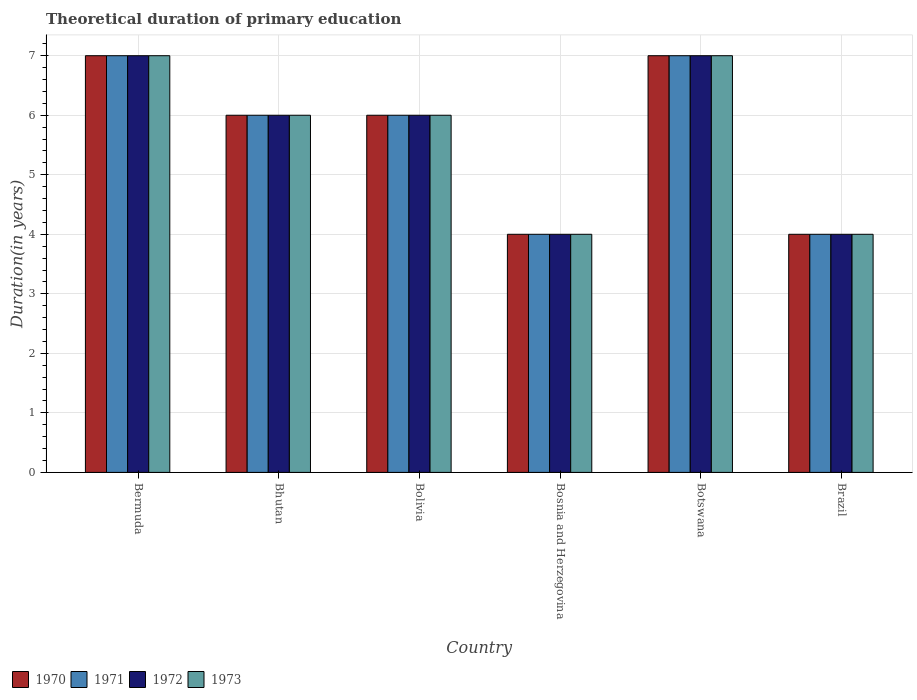How many different coloured bars are there?
Your answer should be compact. 4. Are the number of bars per tick equal to the number of legend labels?
Provide a succinct answer. Yes. How many bars are there on the 1st tick from the left?
Your answer should be very brief. 4. What is the label of the 6th group of bars from the left?
Ensure brevity in your answer.  Brazil. In how many cases, is the number of bars for a given country not equal to the number of legend labels?
Your answer should be very brief. 0. Across all countries, what is the minimum total theoretical duration of primary education in 1973?
Your answer should be compact. 4. In which country was the total theoretical duration of primary education in 1972 maximum?
Keep it short and to the point. Bermuda. In which country was the total theoretical duration of primary education in 1971 minimum?
Your answer should be compact. Bosnia and Herzegovina. What is the average total theoretical duration of primary education in 1970 per country?
Your answer should be compact. 5.67. What is the difference between the total theoretical duration of primary education of/in 1970 and total theoretical duration of primary education of/in 1971 in Botswana?
Give a very brief answer. 0. Is the difference between the total theoretical duration of primary education in 1970 in Bolivia and Bosnia and Herzegovina greater than the difference between the total theoretical duration of primary education in 1971 in Bolivia and Bosnia and Herzegovina?
Offer a terse response. No. What is the difference between the highest and the second highest total theoretical duration of primary education in 1973?
Offer a very short reply. -1. Is the sum of the total theoretical duration of primary education in 1972 in Bermuda and Bosnia and Herzegovina greater than the maximum total theoretical duration of primary education in 1971 across all countries?
Ensure brevity in your answer.  Yes. What does the 2nd bar from the left in Botswana represents?
Provide a succinct answer. 1971. How many bars are there?
Provide a short and direct response. 24. How many countries are there in the graph?
Offer a very short reply. 6. What is the difference between two consecutive major ticks on the Y-axis?
Ensure brevity in your answer.  1. Where does the legend appear in the graph?
Keep it short and to the point. Bottom left. What is the title of the graph?
Offer a very short reply. Theoretical duration of primary education. Does "1972" appear as one of the legend labels in the graph?
Keep it short and to the point. Yes. What is the label or title of the Y-axis?
Your response must be concise. Duration(in years). What is the Duration(in years) of 1970 in Bermuda?
Provide a short and direct response. 7. What is the Duration(in years) in 1971 in Bermuda?
Your response must be concise. 7. What is the Duration(in years) in 1973 in Bermuda?
Your answer should be very brief. 7. What is the Duration(in years) in 1971 in Bhutan?
Your response must be concise. 6. What is the Duration(in years) of 1973 in Bhutan?
Provide a succinct answer. 6. What is the Duration(in years) in 1971 in Bolivia?
Your answer should be very brief. 6. What is the Duration(in years) of 1972 in Bosnia and Herzegovina?
Offer a very short reply. 4. What is the Duration(in years) of 1970 in Botswana?
Offer a terse response. 7. What is the Duration(in years) of 1971 in Botswana?
Your answer should be very brief. 7. What is the Duration(in years) of 1972 in Botswana?
Offer a terse response. 7. What is the Duration(in years) in 1970 in Brazil?
Your answer should be compact. 4. What is the Duration(in years) of 1972 in Brazil?
Offer a very short reply. 4. Across all countries, what is the maximum Duration(in years) in 1970?
Your response must be concise. 7. Across all countries, what is the maximum Duration(in years) in 1971?
Your response must be concise. 7. Across all countries, what is the maximum Duration(in years) in 1972?
Keep it short and to the point. 7. Across all countries, what is the maximum Duration(in years) in 1973?
Ensure brevity in your answer.  7. Across all countries, what is the minimum Duration(in years) in 1972?
Your answer should be compact. 4. What is the total Duration(in years) of 1972 in the graph?
Offer a very short reply. 34. What is the difference between the Duration(in years) in 1970 in Bermuda and that in Bhutan?
Keep it short and to the point. 1. What is the difference between the Duration(in years) in 1971 in Bermuda and that in Bhutan?
Make the answer very short. 1. What is the difference between the Duration(in years) in 1972 in Bermuda and that in Bhutan?
Your answer should be compact. 1. What is the difference between the Duration(in years) in 1973 in Bermuda and that in Bhutan?
Offer a very short reply. 1. What is the difference between the Duration(in years) of 1970 in Bermuda and that in Bolivia?
Give a very brief answer. 1. What is the difference between the Duration(in years) of 1971 in Bermuda and that in Bolivia?
Give a very brief answer. 1. What is the difference between the Duration(in years) of 1972 in Bermuda and that in Bosnia and Herzegovina?
Provide a short and direct response. 3. What is the difference between the Duration(in years) of 1973 in Bermuda and that in Bosnia and Herzegovina?
Ensure brevity in your answer.  3. What is the difference between the Duration(in years) of 1972 in Bermuda and that in Botswana?
Provide a succinct answer. 0. What is the difference between the Duration(in years) of 1973 in Bermuda and that in Botswana?
Your answer should be very brief. 0. What is the difference between the Duration(in years) of 1970 in Bermuda and that in Brazil?
Ensure brevity in your answer.  3. What is the difference between the Duration(in years) of 1972 in Bermuda and that in Brazil?
Your answer should be very brief. 3. What is the difference between the Duration(in years) in 1970 in Bhutan and that in Bolivia?
Ensure brevity in your answer.  0. What is the difference between the Duration(in years) in 1971 in Bhutan and that in Bolivia?
Keep it short and to the point. 0. What is the difference between the Duration(in years) in 1972 in Bhutan and that in Bolivia?
Provide a short and direct response. 0. What is the difference between the Duration(in years) of 1973 in Bhutan and that in Bolivia?
Your answer should be very brief. 0. What is the difference between the Duration(in years) of 1970 in Bhutan and that in Bosnia and Herzegovina?
Give a very brief answer. 2. What is the difference between the Duration(in years) of 1971 in Bhutan and that in Bosnia and Herzegovina?
Give a very brief answer. 2. What is the difference between the Duration(in years) in 1972 in Bhutan and that in Bosnia and Herzegovina?
Your answer should be compact. 2. What is the difference between the Duration(in years) in 1971 in Bhutan and that in Botswana?
Make the answer very short. -1. What is the difference between the Duration(in years) of 1970 in Bhutan and that in Brazil?
Give a very brief answer. 2. What is the difference between the Duration(in years) in 1970 in Bolivia and that in Bosnia and Herzegovina?
Your response must be concise. 2. What is the difference between the Duration(in years) of 1971 in Bolivia and that in Bosnia and Herzegovina?
Provide a succinct answer. 2. What is the difference between the Duration(in years) of 1972 in Bolivia and that in Bosnia and Herzegovina?
Offer a terse response. 2. What is the difference between the Duration(in years) of 1970 in Bolivia and that in Brazil?
Provide a short and direct response. 2. What is the difference between the Duration(in years) in 1972 in Bolivia and that in Brazil?
Provide a short and direct response. 2. What is the difference between the Duration(in years) of 1971 in Bosnia and Herzegovina and that in Botswana?
Ensure brevity in your answer.  -3. What is the difference between the Duration(in years) of 1972 in Bosnia and Herzegovina and that in Botswana?
Offer a terse response. -3. What is the difference between the Duration(in years) in 1970 in Bosnia and Herzegovina and that in Brazil?
Keep it short and to the point. 0. What is the difference between the Duration(in years) of 1971 in Bosnia and Herzegovina and that in Brazil?
Ensure brevity in your answer.  0. What is the difference between the Duration(in years) in 1972 in Bosnia and Herzegovina and that in Brazil?
Give a very brief answer. 0. What is the difference between the Duration(in years) in 1971 in Botswana and that in Brazil?
Provide a short and direct response. 3. What is the difference between the Duration(in years) of 1972 in Botswana and that in Brazil?
Provide a succinct answer. 3. What is the difference between the Duration(in years) in 1970 in Bermuda and the Duration(in years) in 1971 in Bhutan?
Offer a very short reply. 1. What is the difference between the Duration(in years) in 1970 in Bermuda and the Duration(in years) in 1972 in Bhutan?
Provide a short and direct response. 1. What is the difference between the Duration(in years) of 1971 in Bermuda and the Duration(in years) of 1972 in Bhutan?
Provide a short and direct response. 1. What is the difference between the Duration(in years) in 1971 in Bermuda and the Duration(in years) in 1973 in Bhutan?
Your answer should be very brief. 1. What is the difference between the Duration(in years) of 1972 in Bermuda and the Duration(in years) of 1973 in Bhutan?
Your response must be concise. 1. What is the difference between the Duration(in years) of 1970 in Bermuda and the Duration(in years) of 1971 in Bolivia?
Your answer should be very brief. 1. What is the difference between the Duration(in years) of 1970 in Bermuda and the Duration(in years) of 1972 in Bolivia?
Provide a short and direct response. 1. What is the difference between the Duration(in years) in 1971 in Bermuda and the Duration(in years) in 1972 in Bolivia?
Ensure brevity in your answer.  1. What is the difference between the Duration(in years) of 1971 in Bermuda and the Duration(in years) of 1973 in Bolivia?
Your answer should be very brief. 1. What is the difference between the Duration(in years) of 1972 in Bermuda and the Duration(in years) of 1973 in Bolivia?
Keep it short and to the point. 1. What is the difference between the Duration(in years) in 1970 in Bermuda and the Duration(in years) in 1972 in Bosnia and Herzegovina?
Give a very brief answer. 3. What is the difference between the Duration(in years) in 1970 in Bermuda and the Duration(in years) in 1973 in Bosnia and Herzegovina?
Give a very brief answer. 3. What is the difference between the Duration(in years) in 1972 in Bermuda and the Duration(in years) in 1973 in Bosnia and Herzegovina?
Offer a terse response. 3. What is the difference between the Duration(in years) of 1970 in Bermuda and the Duration(in years) of 1973 in Botswana?
Your response must be concise. 0. What is the difference between the Duration(in years) in 1971 in Bermuda and the Duration(in years) in 1972 in Botswana?
Provide a short and direct response. 0. What is the difference between the Duration(in years) in 1972 in Bermuda and the Duration(in years) in 1973 in Botswana?
Your response must be concise. 0. What is the difference between the Duration(in years) of 1970 in Bermuda and the Duration(in years) of 1971 in Brazil?
Keep it short and to the point. 3. What is the difference between the Duration(in years) in 1970 in Bermuda and the Duration(in years) in 1973 in Brazil?
Provide a short and direct response. 3. What is the difference between the Duration(in years) of 1970 in Bhutan and the Duration(in years) of 1973 in Bolivia?
Offer a terse response. 0. What is the difference between the Duration(in years) in 1971 in Bhutan and the Duration(in years) in 1972 in Bolivia?
Your response must be concise. 0. What is the difference between the Duration(in years) in 1971 in Bhutan and the Duration(in years) in 1973 in Bolivia?
Your answer should be compact. 0. What is the difference between the Duration(in years) of 1971 in Bhutan and the Duration(in years) of 1973 in Bosnia and Herzegovina?
Your answer should be compact. 2. What is the difference between the Duration(in years) of 1972 in Bhutan and the Duration(in years) of 1973 in Bosnia and Herzegovina?
Offer a terse response. 2. What is the difference between the Duration(in years) in 1970 in Bhutan and the Duration(in years) in 1971 in Botswana?
Make the answer very short. -1. What is the difference between the Duration(in years) of 1971 in Bhutan and the Duration(in years) of 1972 in Botswana?
Offer a very short reply. -1. What is the difference between the Duration(in years) of 1971 in Bhutan and the Duration(in years) of 1973 in Botswana?
Provide a succinct answer. -1. What is the difference between the Duration(in years) of 1970 in Bhutan and the Duration(in years) of 1971 in Brazil?
Provide a succinct answer. 2. What is the difference between the Duration(in years) of 1970 in Bhutan and the Duration(in years) of 1972 in Brazil?
Your answer should be very brief. 2. What is the difference between the Duration(in years) of 1971 in Bhutan and the Duration(in years) of 1972 in Brazil?
Provide a succinct answer. 2. What is the difference between the Duration(in years) in 1972 in Bhutan and the Duration(in years) in 1973 in Brazil?
Ensure brevity in your answer.  2. What is the difference between the Duration(in years) of 1970 in Bolivia and the Duration(in years) of 1971 in Bosnia and Herzegovina?
Ensure brevity in your answer.  2. What is the difference between the Duration(in years) in 1971 in Bolivia and the Duration(in years) in 1973 in Bosnia and Herzegovina?
Offer a terse response. 2. What is the difference between the Duration(in years) of 1972 in Bolivia and the Duration(in years) of 1973 in Bosnia and Herzegovina?
Your answer should be compact. 2. What is the difference between the Duration(in years) in 1970 in Bolivia and the Duration(in years) in 1971 in Botswana?
Your answer should be compact. -1. What is the difference between the Duration(in years) in 1970 in Bolivia and the Duration(in years) in 1972 in Botswana?
Offer a very short reply. -1. What is the difference between the Duration(in years) in 1972 in Bolivia and the Duration(in years) in 1973 in Botswana?
Offer a terse response. -1. What is the difference between the Duration(in years) of 1970 in Bolivia and the Duration(in years) of 1971 in Brazil?
Give a very brief answer. 2. What is the difference between the Duration(in years) of 1970 in Bolivia and the Duration(in years) of 1972 in Brazil?
Your answer should be very brief. 2. What is the difference between the Duration(in years) of 1970 in Bolivia and the Duration(in years) of 1973 in Brazil?
Offer a very short reply. 2. What is the difference between the Duration(in years) in 1971 in Bolivia and the Duration(in years) in 1972 in Brazil?
Offer a terse response. 2. What is the difference between the Duration(in years) of 1971 in Bolivia and the Duration(in years) of 1973 in Brazil?
Keep it short and to the point. 2. What is the difference between the Duration(in years) of 1970 in Bosnia and Herzegovina and the Duration(in years) of 1972 in Botswana?
Give a very brief answer. -3. What is the difference between the Duration(in years) of 1970 in Bosnia and Herzegovina and the Duration(in years) of 1973 in Botswana?
Your answer should be very brief. -3. What is the difference between the Duration(in years) of 1972 in Bosnia and Herzegovina and the Duration(in years) of 1973 in Botswana?
Provide a short and direct response. -3. What is the difference between the Duration(in years) in 1970 in Bosnia and Herzegovina and the Duration(in years) in 1971 in Brazil?
Keep it short and to the point. 0. What is the difference between the Duration(in years) in 1970 in Bosnia and Herzegovina and the Duration(in years) in 1972 in Brazil?
Provide a succinct answer. 0. What is the difference between the Duration(in years) of 1970 in Bosnia and Herzegovina and the Duration(in years) of 1973 in Brazil?
Provide a short and direct response. 0. What is the difference between the Duration(in years) of 1971 in Bosnia and Herzegovina and the Duration(in years) of 1973 in Brazil?
Offer a very short reply. 0. What is the difference between the Duration(in years) in 1972 in Bosnia and Herzegovina and the Duration(in years) in 1973 in Brazil?
Keep it short and to the point. 0. What is the difference between the Duration(in years) in 1970 in Botswana and the Duration(in years) in 1971 in Brazil?
Your answer should be compact. 3. What is the difference between the Duration(in years) of 1970 in Botswana and the Duration(in years) of 1973 in Brazil?
Make the answer very short. 3. What is the difference between the Duration(in years) of 1971 in Botswana and the Duration(in years) of 1973 in Brazil?
Offer a terse response. 3. What is the average Duration(in years) of 1970 per country?
Offer a very short reply. 5.67. What is the average Duration(in years) of 1971 per country?
Your answer should be very brief. 5.67. What is the average Duration(in years) in 1972 per country?
Your answer should be very brief. 5.67. What is the average Duration(in years) of 1973 per country?
Offer a very short reply. 5.67. What is the difference between the Duration(in years) of 1970 and Duration(in years) of 1972 in Bermuda?
Provide a succinct answer. 0. What is the difference between the Duration(in years) of 1971 and Duration(in years) of 1973 in Bermuda?
Give a very brief answer. 0. What is the difference between the Duration(in years) in 1970 and Duration(in years) in 1971 in Bhutan?
Your answer should be compact. 0. What is the difference between the Duration(in years) of 1971 and Duration(in years) of 1972 in Bhutan?
Your response must be concise. 0. What is the difference between the Duration(in years) of 1971 and Duration(in years) of 1973 in Bhutan?
Offer a terse response. 0. What is the difference between the Duration(in years) in 1970 and Duration(in years) in 1971 in Bolivia?
Your answer should be compact. 0. What is the difference between the Duration(in years) of 1970 and Duration(in years) of 1972 in Bolivia?
Offer a terse response. 0. What is the difference between the Duration(in years) in 1971 and Duration(in years) in 1972 in Bolivia?
Your answer should be very brief. 0. What is the difference between the Duration(in years) of 1970 and Duration(in years) of 1971 in Bosnia and Herzegovina?
Your answer should be very brief. 0. What is the difference between the Duration(in years) in 1971 and Duration(in years) in 1973 in Bosnia and Herzegovina?
Provide a short and direct response. 0. What is the difference between the Duration(in years) of 1972 and Duration(in years) of 1973 in Bosnia and Herzegovina?
Make the answer very short. 0. What is the difference between the Duration(in years) in 1970 and Duration(in years) in 1971 in Botswana?
Make the answer very short. 0. What is the difference between the Duration(in years) of 1970 and Duration(in years) of 1972 in Botswana?
Your response must be concise. 0. What is the difference between the Duration(in years) in 1970 and Duration(in years) in 1973 in Botswana?
Make the answer very short. 0. What is the difference between the Duration(in years) of 1971 and Duration(in years) of 1973 in Brazil?
Your response must be concise. 0. What is the ratio of the Duration(in years) in 1971 in Bermuda to that in Bhutan?
Your response must be concise. 1.17. What is the ratio of the Duration(in years) of 1973 in Bermuda to that in Bhutan?
Provide a succinct answer. 1.17. What is the ratio of the Duration(in years) in 1970 in Bermuda to that in Bolivia?
Make the answer very short. 1.17. What is the ratio of the Duration(in years) of 1971 in Bermuda to that in Bolivia?
Make the answer very short. 1.17. What is the ratio of the Duration(in years) in 1973 in Bermuda to that in Bolivia?
Offer a terse response. 1.17. What is the ratio of the Duration(in years) in 1971 in Bermuda to that in Botswana?
Offer a very short reply. 1. What is the ratio of the Duration(in years) in 1973 in Bermuda to that in Botswana?
Offer a very short reply. 1. What is the ratio of the Duration(in years) of 1971 in Bermuda to that in Brazil?
Give a very brief answer. 1.75. What is the ratio of the Duration(in years) of 1973 in Bermuda to that in Brazil?
Your response must be concise. 1.75. What is the ratio of the Duration(in years) in 1970 in Bhutan to that in Bolivia?
Your answer should be compact. 1. What is the ratio of the Duration(in years) of 1973 in Bhutan to that in Bosnia and Herzegovina?
Make the answer very short. 1.5. What is the ratio of the Duration(in years) of 1970 in Bhutan to that in Botswana?
Provide a short and direct response. 0.86. What is the ratio of the Duration(in years) of 1971 in Bhutan to that in Botswana?
Your response must be concise. 0.86. What is the ratio of the Duration(in years) in 1970 in Bhutan to that in Brazil?
Provide a succinct answer. 1.5. What is the ratio of the Duration(in years) of 1972 in Bhutan to that in Brazil?
Ensure brevity in your answer.  1.5. What is the ratio of the Duration(in years) of 1970 in Bolivia to that in Bosnia and Herzegovina?
Your answer should be compact. 1.5. What is the ratio of the Duration(in years) of 1971 in Bolivia to that in Bosnia and Herzegovina?
Give a very brief answer. 1.5. What is the ratio of the Duration(in years) in 1973 in Bolivia to that in Bosnia and Herzegovina?
Your answer should be very brief. 1.5. What is the ratio of the Duration(in years) in 1971 in Bolivia to that in Botswana?
Provide a succinct answer. 0.86. What is the ratio of the Duration(in years) of 1972 in Bolivia to that in Botswana?
Offer a terse response. 0.86. What is the ratio of the Duration(in years) in 1973 in Bolivia to that in Botswana?
Provide a succinct answer. 0.86. What is the ratio of the Duration(in years) of 1971 in Bolivia to that in Brazil?
Your response must be concise. 1.5. What is the ratio of the Duration(in years) in 1970 in Bosnia and Herzegovina to that in Botswana?
Keep it short and to the point. 0.57. What is the ratio of the Duration(in years) of 1973 in Bosnia and Herzegovina to that in Botswana?
Make the answer very short. 0.57. What is the ratio of the Duration(in years) of 1971 in Bosnia and Herzegovina to that in Brazil?
Ensure brevity in your answer.  1. What is the ratio of the Duration(in years) in 1973 in Bosnia and Herzegovina to that in Brazil?
Provide a succinct answer. 1. What is the ratio of the Duration(in years) of 1972 in Botswana to that in Brazil?
Your answer should be very brief. 1.75. What is the ratio of the Duration(in years) of 1973 in Botswana to that in Brazil?
Provide a short and direct response. 1.75. What is the difference between the highest and the second highest Duration(in years) in 1973?
Offer a terse response. 0. What is the difference between the highest and the lowest Duration(in years) of 1972?
Your answer should be very brief. 3. What is the difference between the highest and the lowest Duration(in years) in 1973?
Ensure brevity in your answer.  3. 